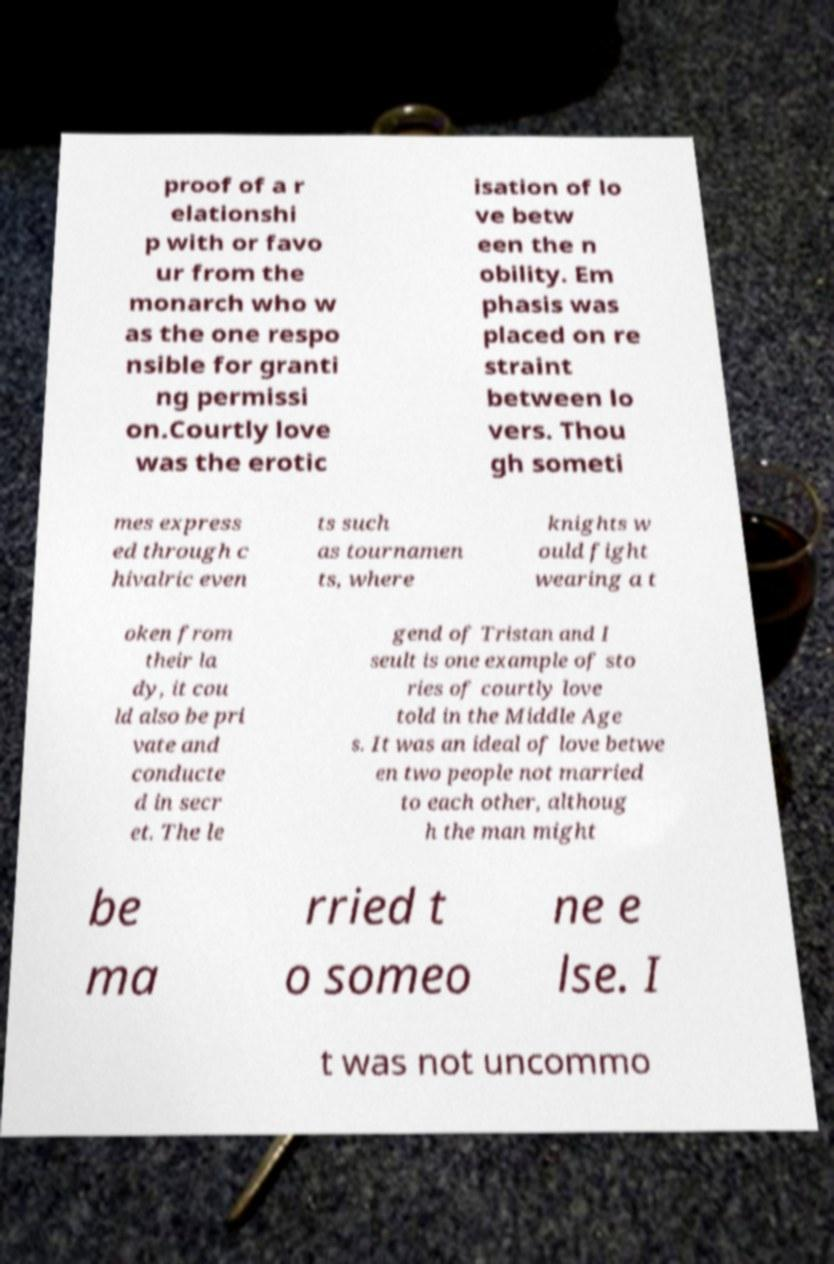Could you assist in decoding the text presented in this image and type it out clearly? proof of a r elationshi p with or favo ur from the monarch who w as the one respo nsible for granti ng permissi on.Courtly love was the erotic isation of lo ve betw een the n obility. Em phasis was placed on re straint between lo vers. Thou gh someti mes express ed through c hivalric even ts such as tournamen ts, where knights w ould fight wearing a t oken from their la dy, it cou ld also be pri vate and conducte d in secr et. The le gend of Tristan and I seult is one example of sto ries of courtly love told in the Middle Age s. It was an ideal of love betwe en two people not married to each other, althoug h the man might be ma rried t o someo ne e lse. I t was not uncommo 